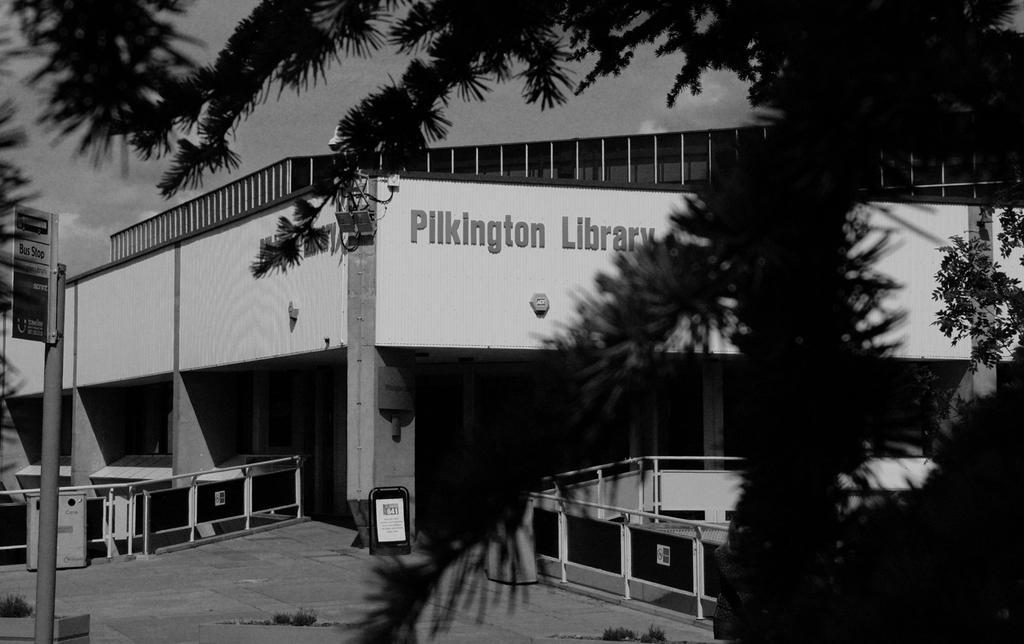Describe this image in one or two sentences. In this image I can see trees in the front. There is a board on the left. There are fences and a building at the back. There is sky at the top. This is a black and white image. 